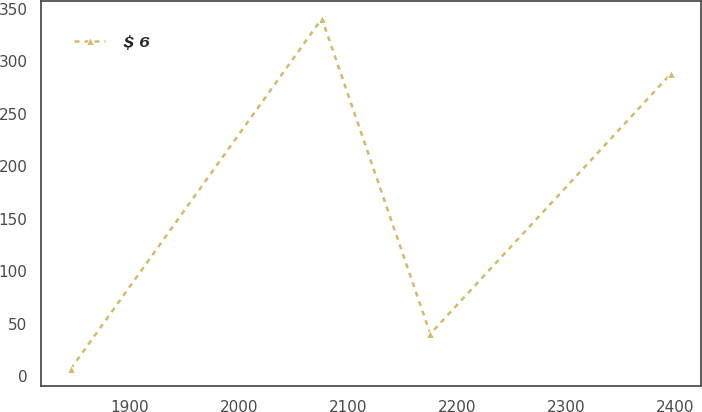Convert chart to OTSL. <chart><loc_0><loc_0><loc_500><loc_500><line_chart><ecel><fcel>$ 6<nl><fcel>1845.61<fcel>6.91<nl><fcel>2075.9<fcel>340.84<nl><fcel>2175.28<fcel>40.3<nl><fcel>2396.01<fcel>288.31<nl></chart> 